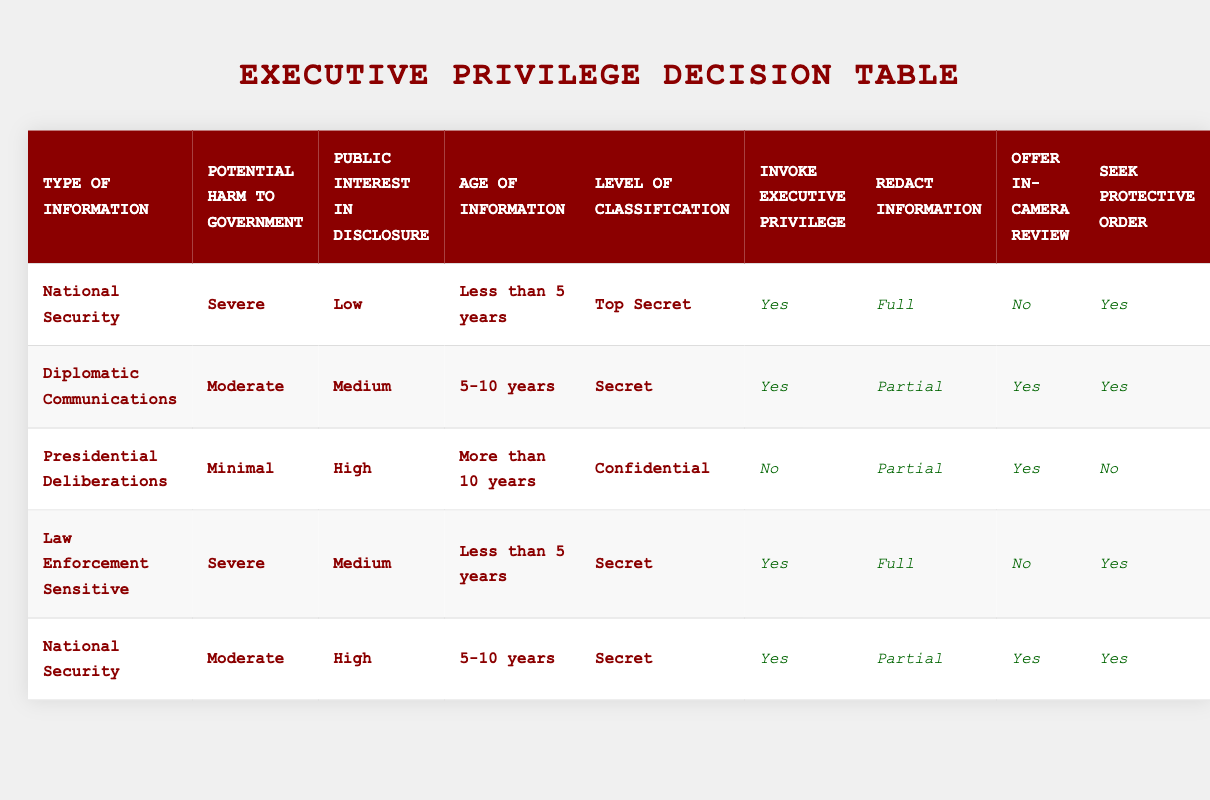What type of information is associated with invoking executive privilege when the potential harm to the government is severe and the public interest in disclosure is low? To answer this, we look for rows in the table where the conditions are 'Severe' for potential harm and 'Low' for public interest. The first row matches these criteria, listing 'National Security' as the type of information.
Answer: National Security How many rows involve invoking executive privilege for information classified as 'Top Secret'? We review the table to check how many rows show 'Invoke Executive Privilege' set to 'Yes' and have 'Top Secret' under Level of Classification. There is one match: the first row. Therefore, the total count is 1.
Answer: 1 Is it true that public interest in disclosure is high for Presidential Deliberations? We check the row for 'Presidential Deliberations' and find that the public interest in disclosure is labeled as 'High'. Therefore, the statement is true.
Answer: Yes What action is taken regarding information that is 'Law Enforcement Sensitive' and has a 'Moderate' potential harm? For 'Law Enforcement Sensitive' with 'Moderate' potential harm, we look at the table and see no entries with these specific conditions. Thus, the action regarding invoking executive privilege in that case cannot be determined from the table.
Answer: None When the age of information is '5-10 years', how does the action of seeking a protective order compare between the different types of information? We check all rows where the age is '5-10 years'. In the second row, we have a 'Yes' for seeking a protective order under 'Diplomatic Communications', and the last row also indicates 'Yes' under 'National Security'. Therefore, the comparison shows two types of information with 'Yes' to seeking a protective order.
Answer: Yes, for both types What is the difference in possible actions between information classified as 'Top Secret' and that classified as 'Confidential'? Analyzing the table, information classified as 'Top Secret' allows invoking executive privilege along with a full redaction and seeking a protective order (one row), while 'Confidential' does not permit invoking privilege, allows partial redaction, and does not meet the requirement for a protective order (one row). Therefore, the key difference is the invoking of executive privilege and the full redaction.
Answer: Redaction and privilege differ by classification For information types experiencing 'Severe' potential harm, which redaction is mostly applied? We look at the rows with 'Severe' potential harm; there are two rows, one with 'Full' redaction for 'National Security' and another with 'Full' redaction for 'Law Enforcement Sensitive’. Therefore, 'Full' is primarily applied for the severe category.
Answer: Full Is there any instance where information with 'Minimal' potential harm still results in invoking executive privilege? We review the table for any instance where potential harm is listed as 'Minimal'. We find one row for 'Presidential Deliberations' with 'Minimal' harm that indicates invoking executive privilege as 'No'. Thus, there is no instance of invoking privilege under these conditions.
Answer: No 